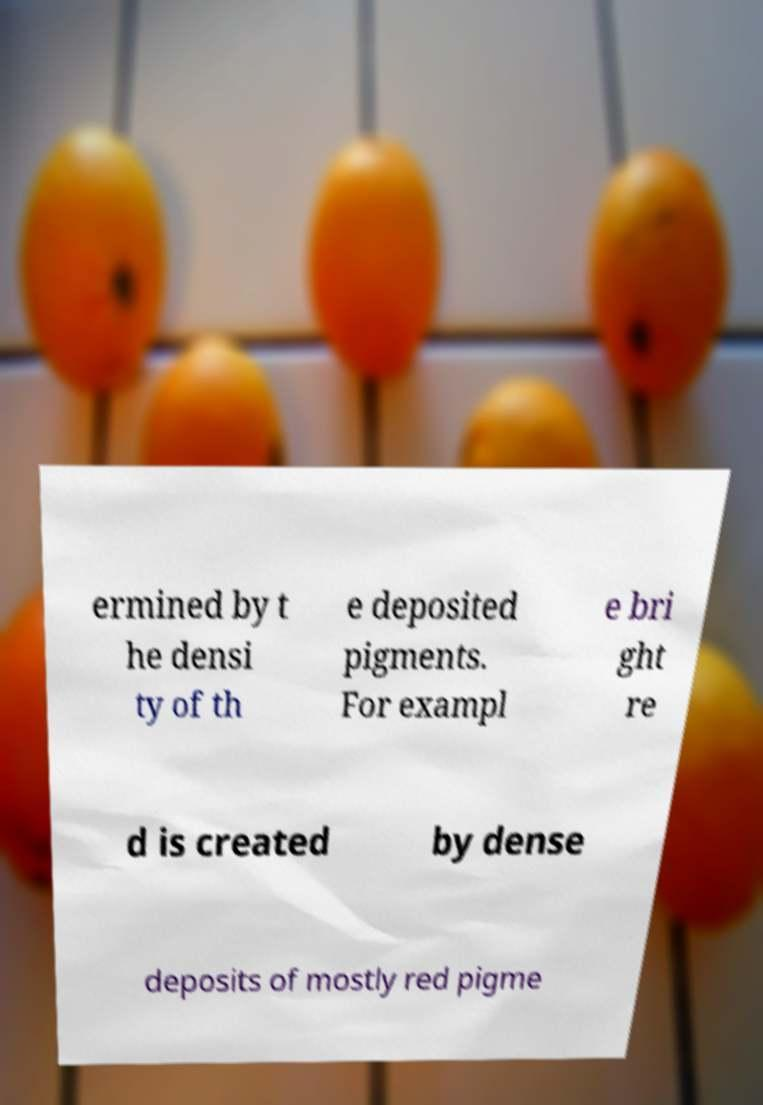Could you extract and type out the text from this image? ermined by t he densi ty of th e deposited pigments. For exampl e bri ght re d is created by dense deposits of mostly red pigme 